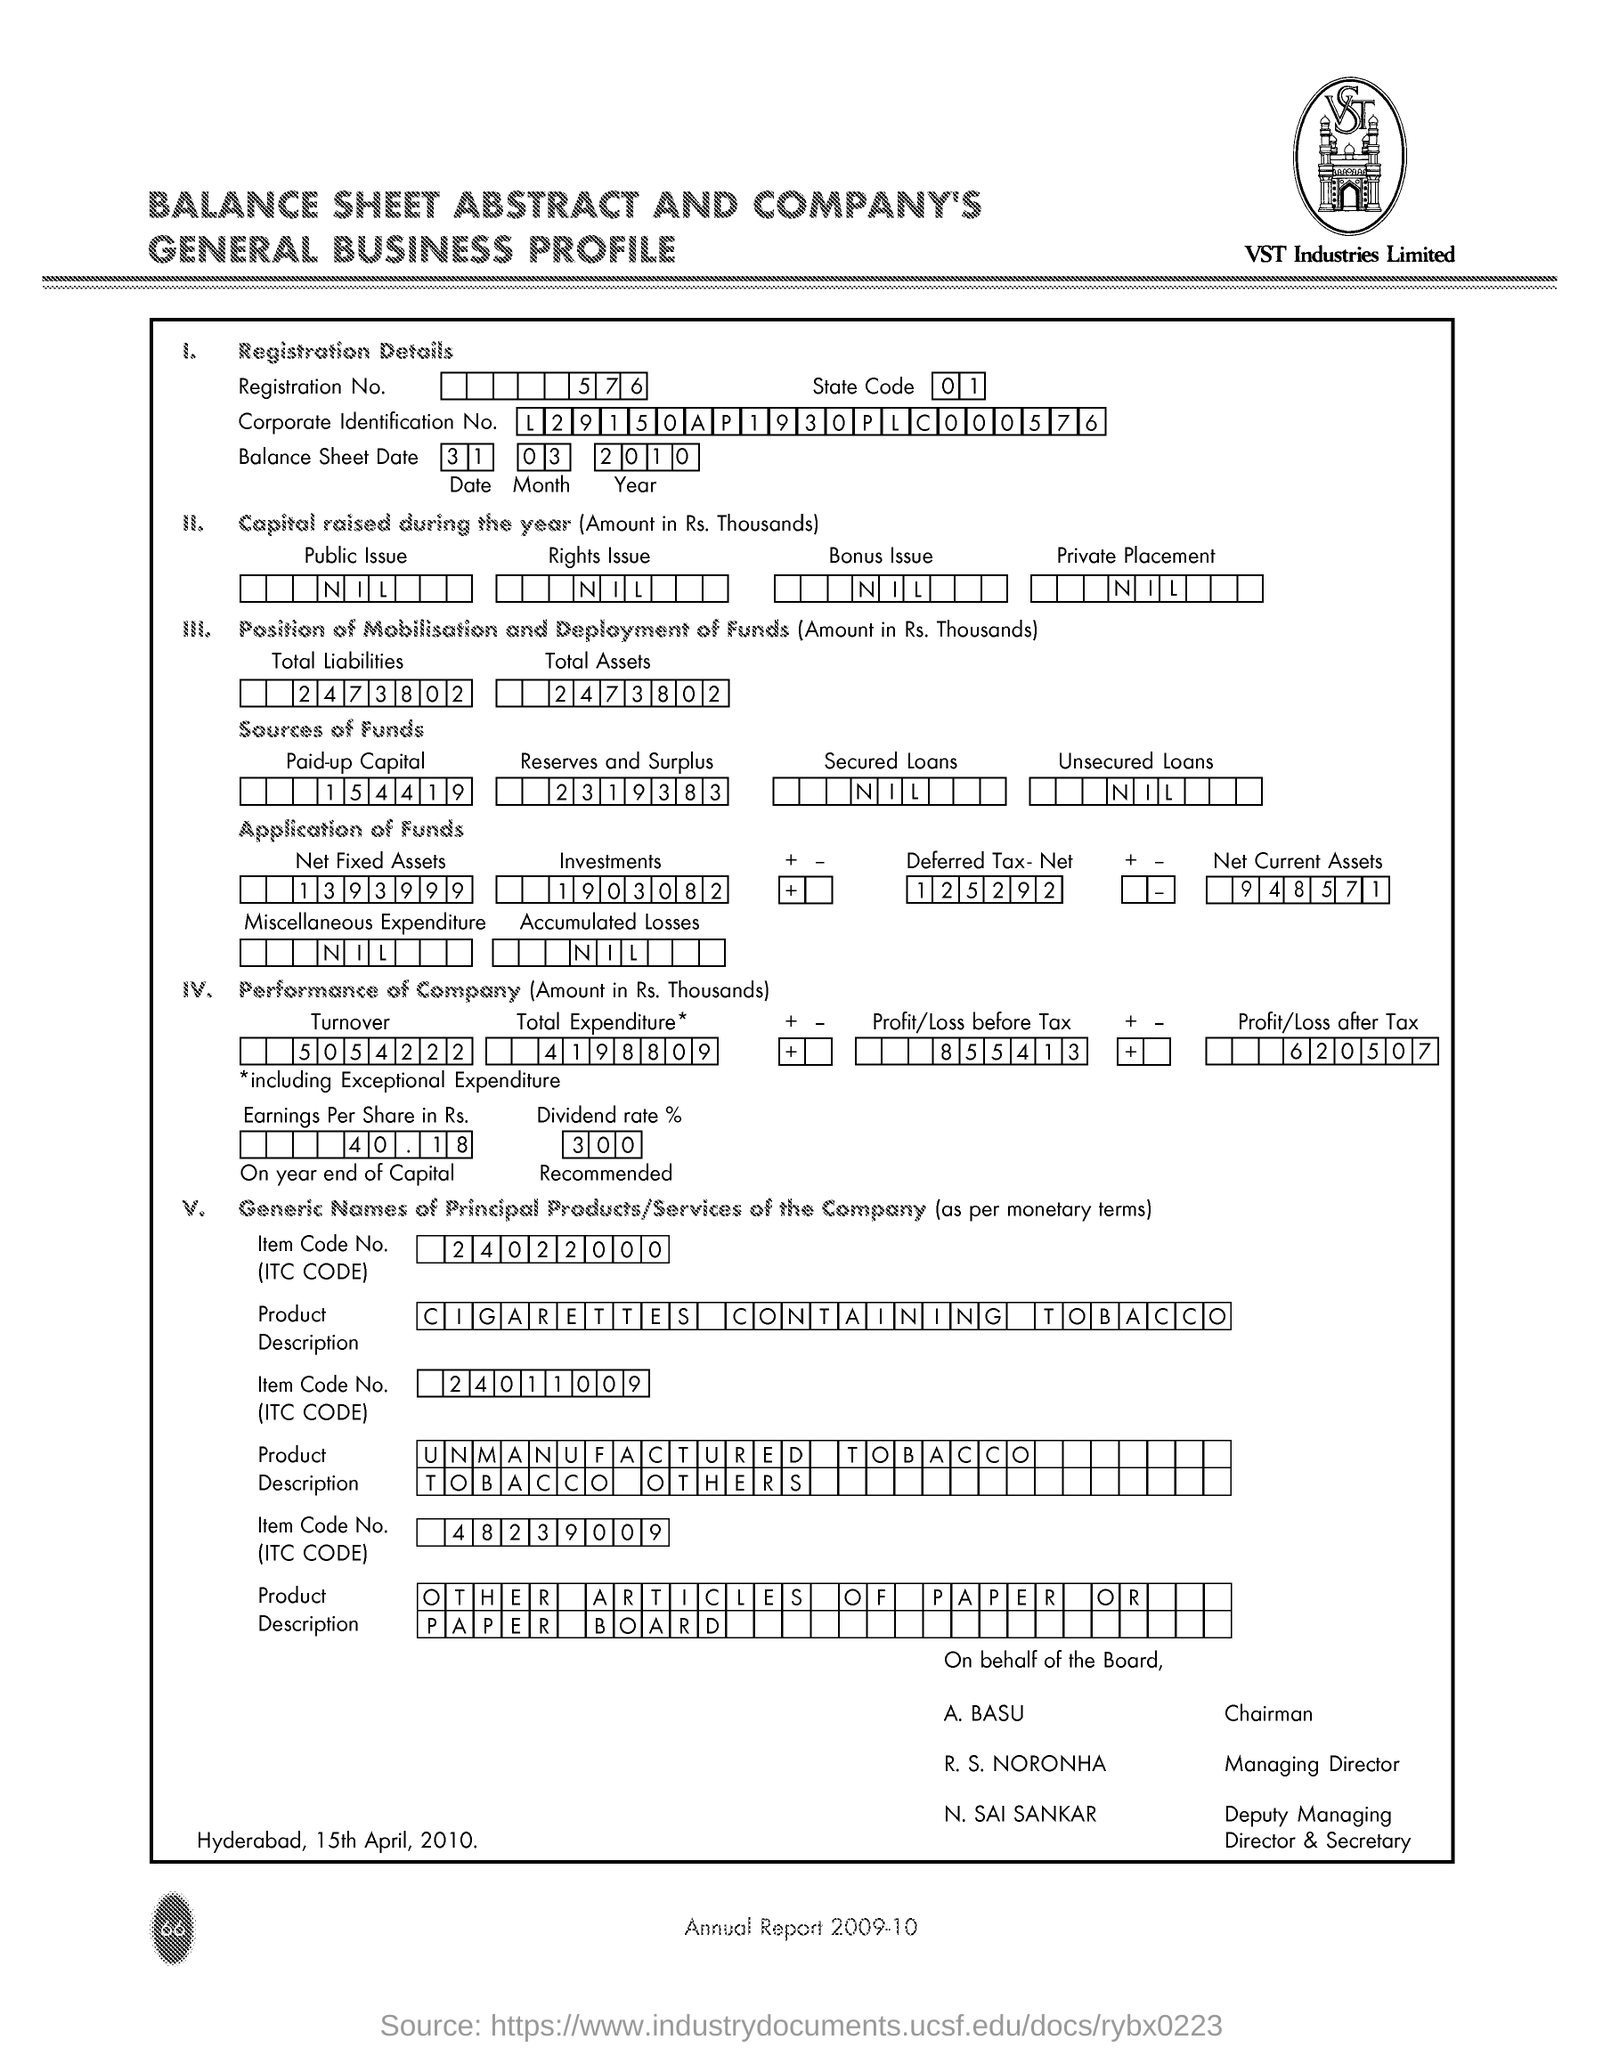Give some essential details in this illustration. The paid up capital is a concept that refers to the total amount of capital invested in a company, including both contributed and guaranteed capital, as of a specified date. The total liability is 247,380,200. What is the balance sheet date of March 31, 2010? A secured loan is a type of loan that is secured by collateral, which means that the borrower pledges an asset, such as a home or car, as security for the loan. However, there is no information available on what a secured loan is. Unsecured loans are loans that are not secured by any form of collateral, such as a car or property. They are often used by individuals or businesses that do not have the assets to offer as security for a loan. 